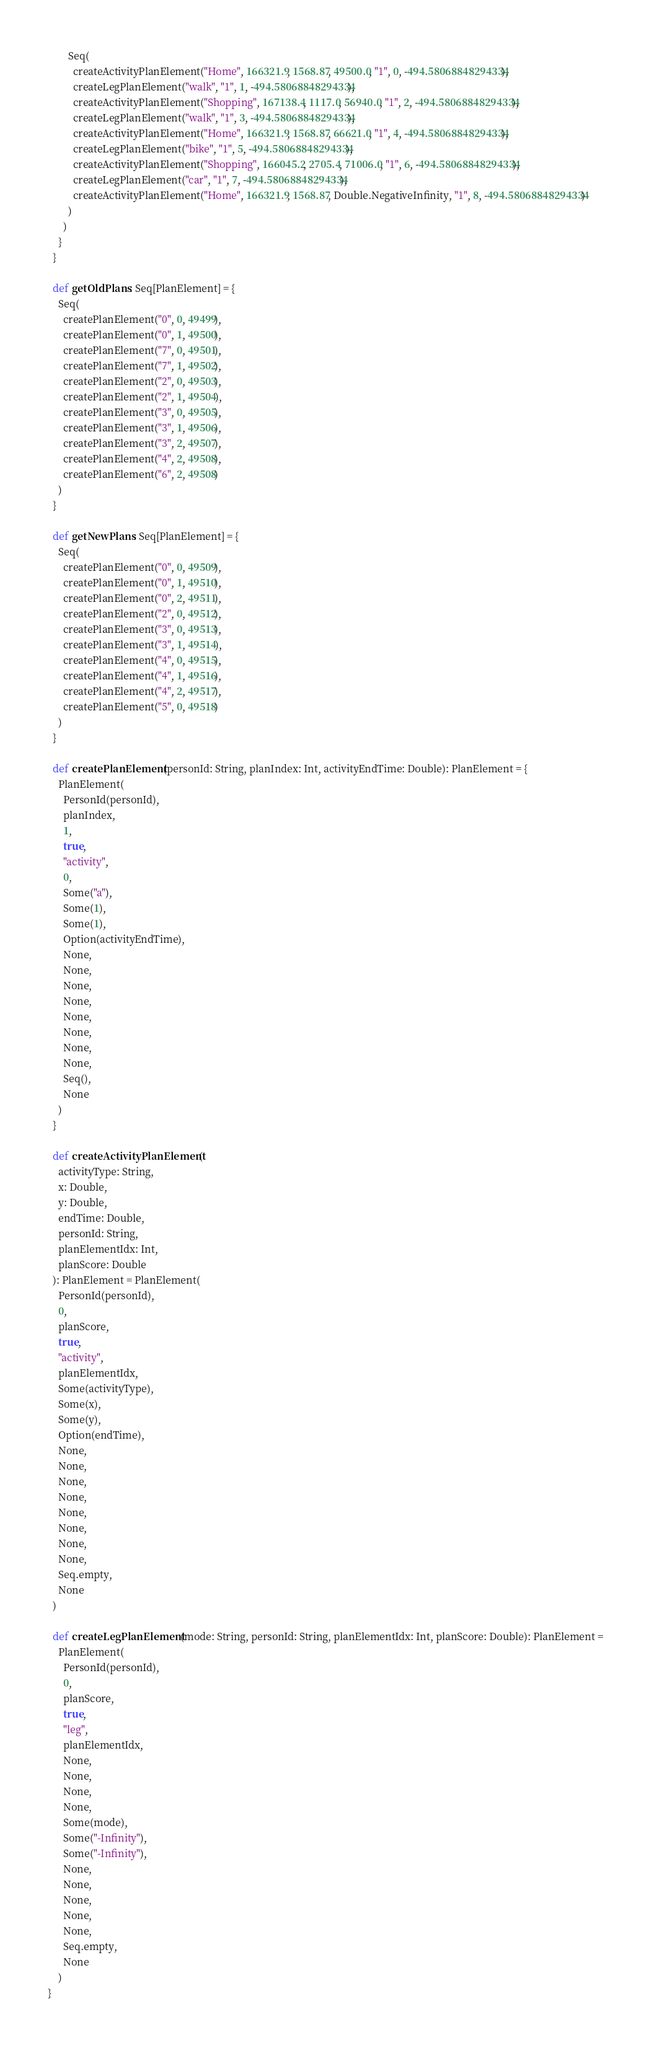<code> <loc_0><loc_0><loc_500><loc_500><_Scala_>        Seq(
          createActivityPlanElement("Home", 166321.9, 1568.87, 49500.0, "1", 0, -494.58068848294334),
          createLegPlanElement("walk", "1", 1, -494.58068848294334),
          createActivityPlanElement("Shopping", 167138.4, 1117.0, 56940.0, "1", 2, -494.58068848294334),
          createLegPlanElement("walk", "1", 3, -494.58068848294334),
          createActivityPlanElement("Home", 166321.9, 1568.87, 66621.0, "1", 4, -494.58068848294334),
          createLegPlanElement("bike", "1", 5, -494.58068848294334),
          createActivityPlanElement("Shopping", 166045.2, 2705.4, 71006.0, "1", 6, -494.58068848294334),
          createLegPlanElement("car", "1", 7, -494.58068848294334),
          createActivityPlanElement("Home", 166321.9, 1568.87, Double.NegativeInfinity, "1", 8, -494.58068848294334)
        )
      )
    }
  }

  def getOldPlans: Seq[PlanElement] = {
    Seq(
      createPlanElement("0", 0, 49499),
      createPlanElement("0", 1, 49500),
      createPlanElement("7", 0, 49501),
      createPlanElement("7", 1, 49502),
      createPlanElement("2", 0, 49503),
      createPlanElement("2", 1, 49504),
      createPlanElement("3", 0, 49505),
      createPlanElement("3", 1, 49506),
      createPlanElement("3", 2, 49507),
      createPlanElement("4", 2, 49508),
      createPlanElement("6", 2, 49508)
    )
  }

  def getNewPlans: Seq[PlanElement] = {
    Seq(
      createPlanElement("0", 0, 49509),
      createPlanElement("0", 1, 49510),
      createPlanElement("0", 2, 49511),
      createPlanElement("2", 0, 49512),
      createPlanElement("3", 0, 49513),
      createPlanElement("3", 1, 49514),
      createPlanElement("4", 0, 49515),
      createPlanElement("4", 1, 49516),
      createPlanElement("4", 2, 49517),
      createPlanElement("5", 0, 49518)
    )
  }

  def createPlanElement(personId: String, planIndex: Int, activityEndTime: Double): PlanElement = {
    PlanElement(
      PersonId(personId),
      planIndex,
      1,
      true,
      "activity",
      0,
      Some("a"),
      Some(1),
      Some(1),
      Option(activityEndTime),
      None,
      None,
      None,
      None,
      None,
      None,
      None,
      None,
      Seq(),
      None
    )
  }

  def createActivityPlanElement(
    activityType: String,
    x: Double,
    y: Double,
    endTime: Double,
    personId: String,
    planElementIdx: Int,
    planScore: Double
  ): PlanElement = PlanElement(
    PersonId(personId),
    0,
    planScore,
    true,
    "activity",
    planElementIdx,
    Some(activityType),
    Some(x),
    Some(y),
    Option(endTime),
    None,
    None,
    None,
    None,
    None,
    None,
    None,
    None,
    Seq.empty,
    None
  )

  def createLegPlanElement(mode: String, personId: String, planElementIdx: Int, planScore: Double): PlanElement =
    PlanElement(
      PersonId(personId),
      0,
      planScore,
      true,
      "leg",
      planElementIdx,
      None,
      None,
      None,
      None,
      Some(mode),
      Some("-Infinity"),
      Some("-Infinity"),
      None,
      None,
      None,
      None,
      None,
      Seq.empty,
      None
    )
}
</code> 